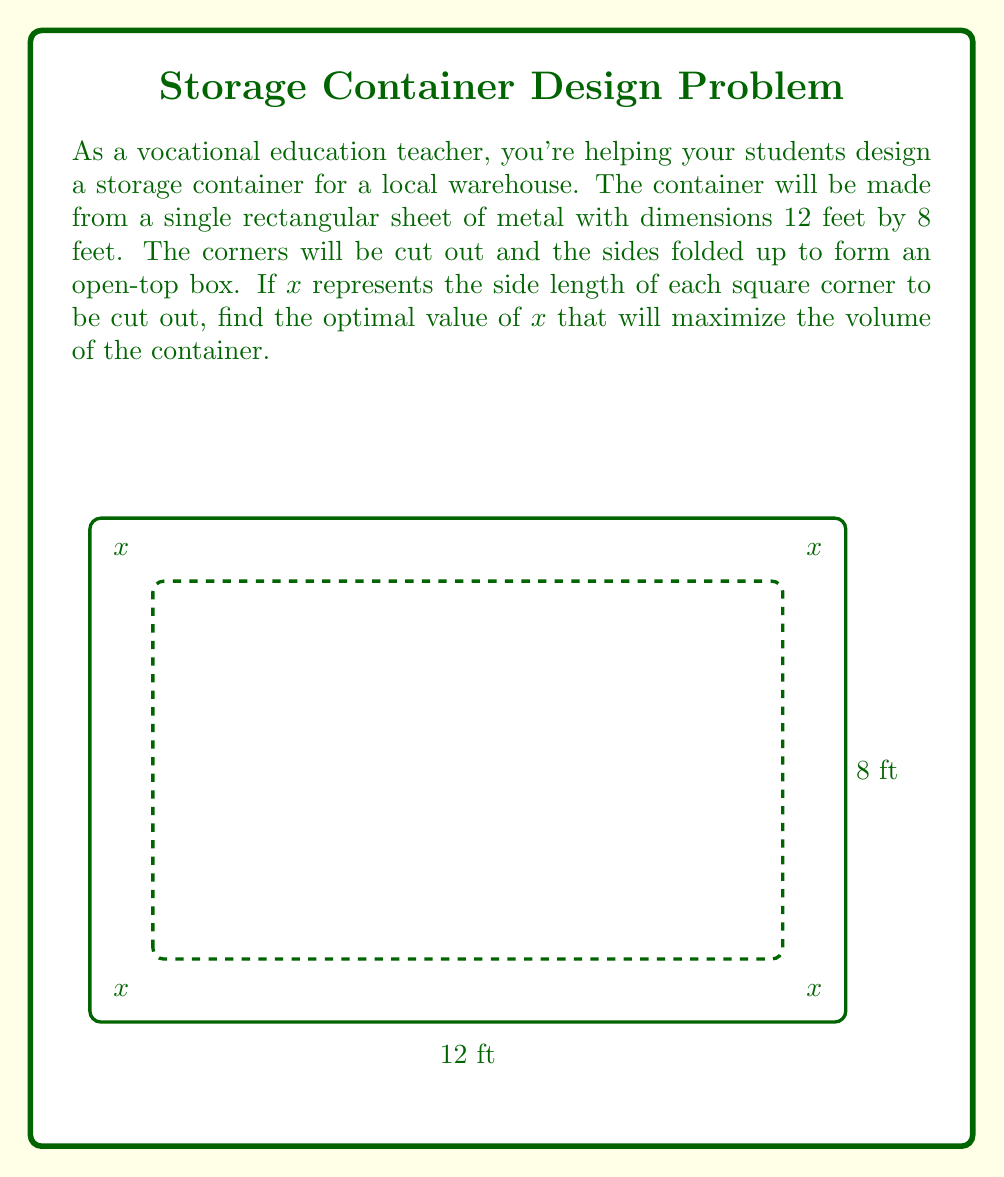Provide a solution to this math problem. Let's approach this step-by-step:

1) First, we need to express the volume of the box in terms of x. The volume is length × width × height.

2) After cutting out the corners:
   Length = 12 - 2x
   Width = 8 - 2x
   Height = x

3) So, the volume function is:
   $$V(x) = (12-2x)(8-2x)(x)$$

4) Expanding this:
   $$V(x) = (96-24x-24x+4x^2)(x)$$
   $$V(x) = 96x-48x^2+4x^3$$

5) To find the maximum volume, we need to find where the derivative of V(x) equals zero:
   $$V'(x) = 96-96x+12x^2$$

6) Set this equal to zero:
   $$96-96x+12x^2 = 0$$

7) This is a quadratic equation. We can solve it using the quadratic formula:
   $$x = \frac{-b \pm \sqrt{b^2-4ac}}{2a}$$
   where $a=12$, $b=-96$, and $c=96$

8) Plugging in these values:
   $$x = \frac{96 \pm \sqrt{(-96)^2-4(12)(96)}}{2(12)}$$
   $$x = \frac{96 \pm \sqrt{9216-4608}}{24}$$
   $$x = \frac{96 \pm \sqrt{4608}}{24}$$
   $$x = \frac{96 \pm 67.88}{24}$$

9) This gives us two solutions:
   $$x_1 = \frac{96 + 67.88}{24} \approx 6.83$$
   $$x_2 = \frac{96 - 67.88}{24} \approx 1.17$$

10) The second derivative of V(x) is:
    $$V''(x) = -96+24x$$
    At $x = 1.17$, $V''(1.17) > 0$, indicating a local minimum.
    At $x = 6.83$, $V''(6.83) < 0$, indicating a local maximum.

Therefore, the optimal value of x that maximizes the volume is approximately 1.17 feet.
Answer: $x \approx 1.17$ feet 